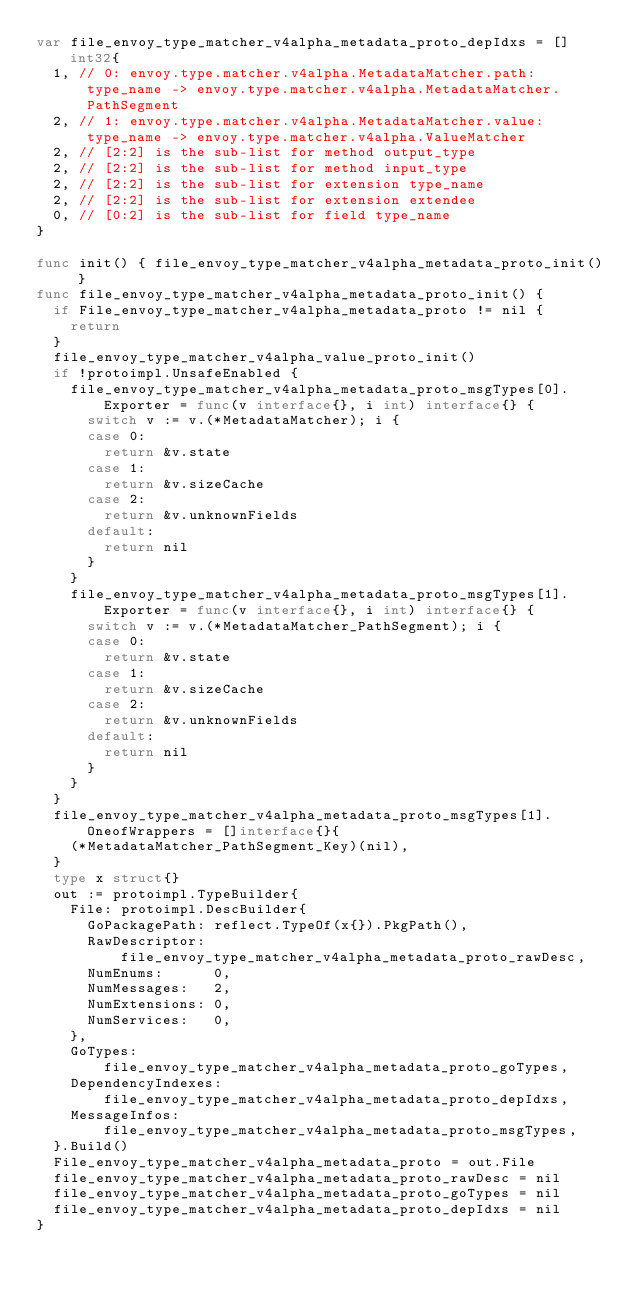<code> <loc_0><loc_0><loc_500><loc_500><_Go_>var file_envoy_type_matcher_v4alpha_metadata_proto_depIdxs = []int32{
	1, // 0: envoy.type.matcher.v4alpha.MetadataMatcher.path:type_name -> envoy.type.matcher.v4alpha.MetadataMatcher.PathSegment
	2, // 1: envoy.type.matcher.v4alpha.MetadataMatcher.value:type_name -> envoy.type.matcher.v4alpha.ValueMatcher
	2, // [2:2] is the sub-list for method output_type
	2, // [2:2] is the sub-list for method input_type
	2, // [2:2] is the sub-list for extension type_name
	2, // [2:2] is the sub-list for extension extendee
	0, // [0:2] is the sub-list for field type_name
}

func init() { file_envoy_type_matcher_v4alpha_metadata_proto_init() }
func file_envoy_type_matcher_v4alpha_metadata_proto_init() {
	if File_envoy_type_matcher_v4alpha_metadata_proto != nil {
		return
	}
	file_envoy_type_matcher_v4alpha_value_proto_init()
	if !protoimpl.UnsafeEnabled {
		file_envoy_type_matcher_v4alpha_metadata_proto_msgTypes[0].Exporter = func(v interface{}, i int) interface{} {
			switch v := v.(*MetadataMatcher); i {
			case 0:
				return &v.state
			case 1:
				return &v.sizeCache
			case 2:
				return &v.unknownFields
			default:
				return nil
			}
		}
		file_envoy_type_matcher_v4alpha_metadata_proto_msgTypes[1].Exporter = func(v interface{}, i int) interface{} {
			switch v := v.(*MetadataMatcher_PathSegment); i {
			case 0:
				return &v.state
			case 1:
				return &v.sizeCache
			case 2:
				return &v.unknownFields
			default:
				return nil
			}
		}
	}
	file_envoy_type_matcher_v4alpha_metadata_proto_msgTypes[1].OneofWrappers = []interface{}{
		(*MetadataMatcher_PathSegment_Key)(nil),
	}
	type x struct{}
	out := protoimpl.TypeBuilder{
		File: protoimpl.DescBuilder{
			GoPackagePath: reflect.TypeOf(x{}).PkgPath(),
			RawDescriptor: file_envoy_type_matcher_v4alpha_metadata_proto_rawDesc,
			NumEnums:      0,
			NumMessages:   2,
			NumExtensions: 0,
			NumServices:   0,
		},
		GoTypes:           file_envoy_type_matcher_v4alpha_metadata_proto_goTypes,
		DependencyIndexes: file_envoy_type_matcher_v4alpha_metadata_proto_depIdxs,
		MessageInfos:      file_envoy_type_matcher_v4alpha_metadata_proto_msgTypes,
	}.Build()
	File_envoy_type_matcher_v4alpha_metadata_proto = out.File
	file_envoy_type_matcher_v4alpha_metadata_proto_rawDesc = nil
	file_envoy_type_matcher_v4alpha_metadata_proto_goTypes = nil
	file_envoy_type_matcher_v4alpha_metadata_proto_depIdxs = nil
}
</code> 